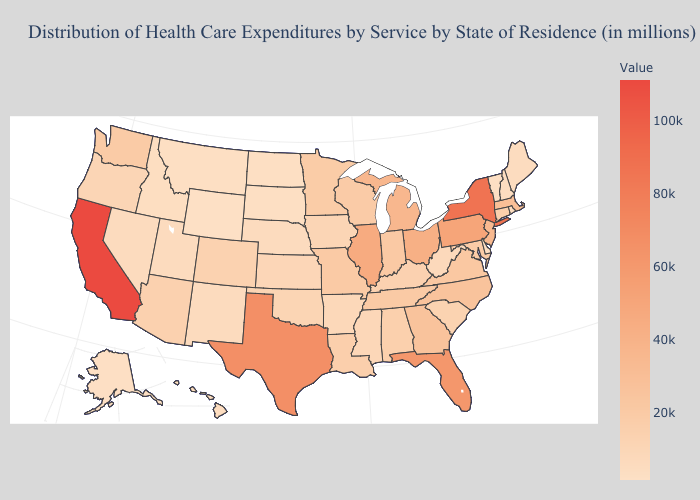Which states have the highest value in the USA?
Answer briefly. California. Does Missouri have the lowest value in the MidWest?
Short answer required. No. Does Arizona have a higher value than Georgia?
Keep it brief. No. Among the states that border Nebraska , which have the highest value?
Concise answer only. Missouri. Among the states that border Washington , does Oregon have the highest value?
Quick response, please. Yes. Among the states that border New York , does Connecticut have the highest value?
Keep it brief. No. Does New Mexico have the lowest value in the West?
Quick response, please. No. 